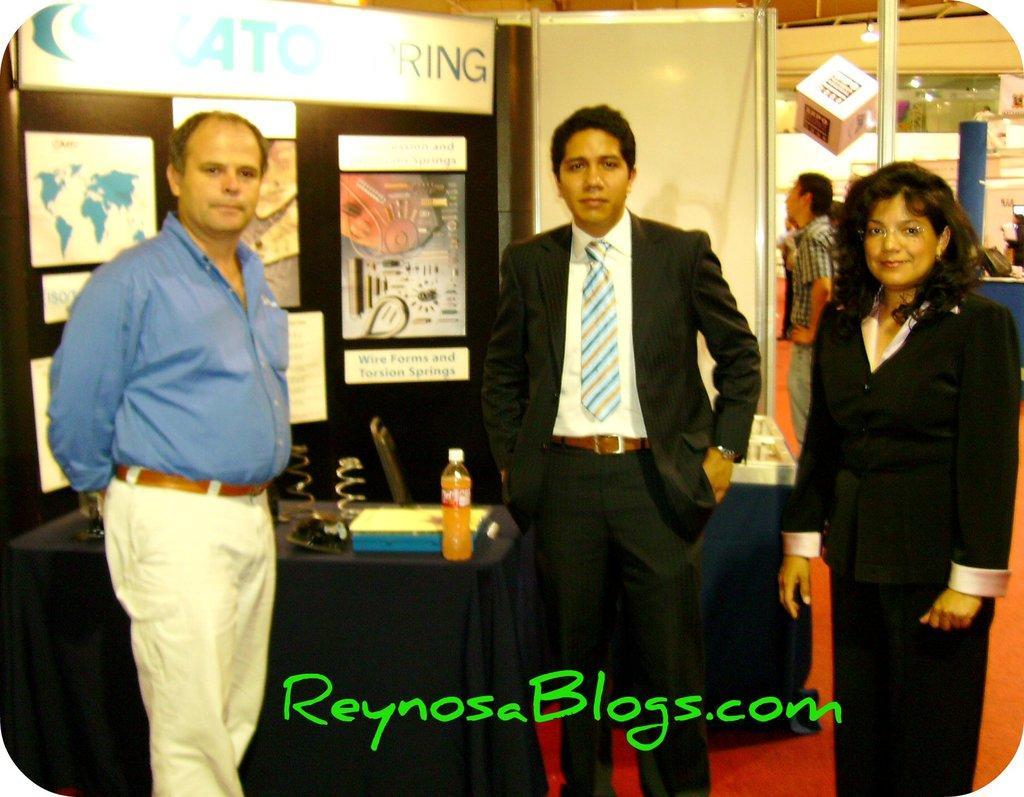Could you give a brief overview of what you see in this image? As we can see in the image there is a wall, banners, few people here and there, chair and a table. On table there is a tray and a bottle. 